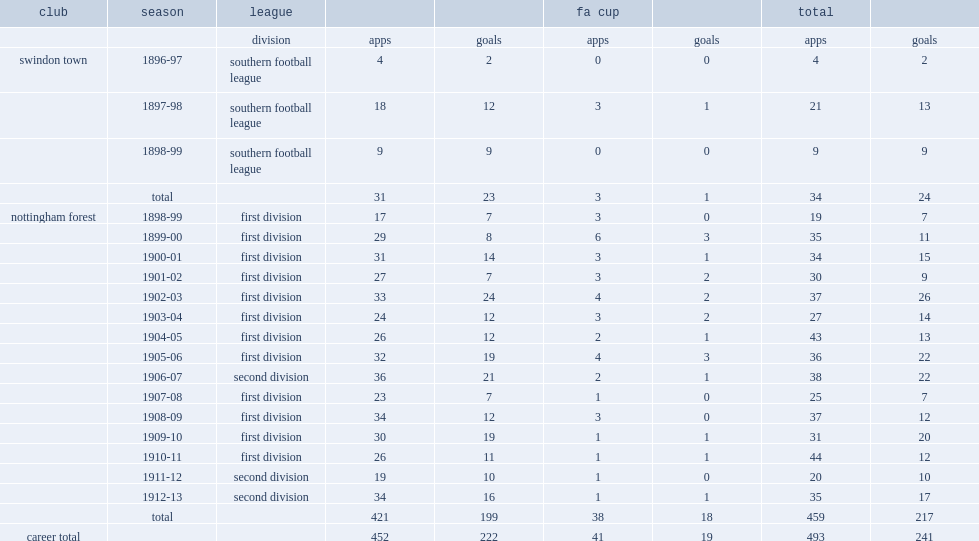How many goals did grenville morris score for the nottingham forest club totally? 217.0. 